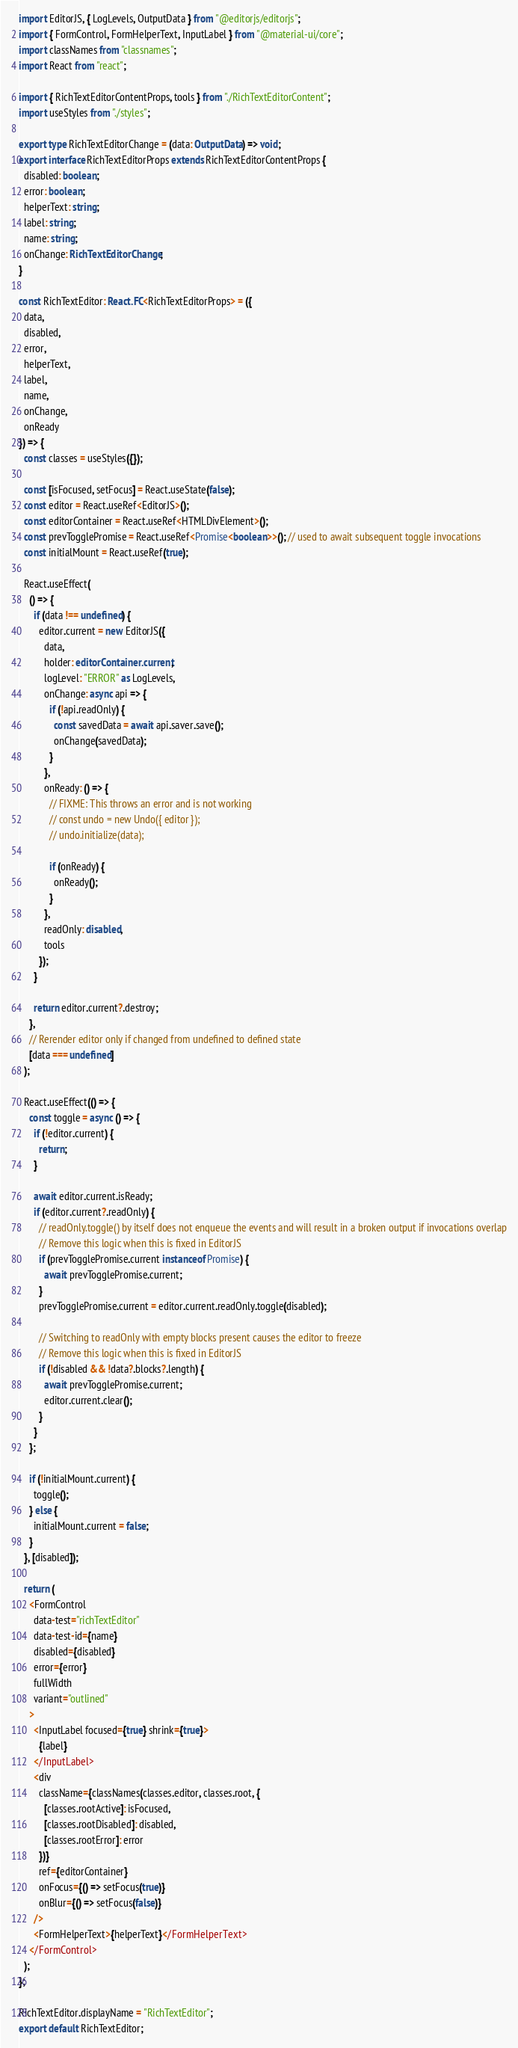<code> <loc_0><loc_0><loc_500><loc_500><_TypeScript_>import EditorJS, { LogLevels, OutputData } from "@editorjs/editorjs";
import { FormControl, FormHelperText, InputLabel } from "@material-ui/core";
import classNames from "classnames";
import React from "react";

import { RichTextEditorContentProps, tools } from "./RichTextEditorContent";
import useStyles from "./styles";

export type RichTextEditorChange = (data: OutputData) => void;
export interface RichTextEditorProps extends RichTextEditorContentProps {
  disabled: boolean;
  error: boolean;
  helperText: string;
  label: string;
  name: string;
  onChange: RichTextEditorChange;
}

const RichTextEditor: React.FC<RichTextEditorProps> = ({
  data,
  disabled,
  error,
  helperText,
  label,
  name,
  onChange,
  onReady
}) => {
  const classes = useStyles({});

  const [isFocused, setFocus] = React.useState(false);
  const editor = React.useRef<EditorJS>();
  const editorContainer = React.useRef<HTMLDivElement>();
  const prevTogglePromise = React.useRef<Promise<boolean>>(); // used to await subsequent toggle invocations
  const initialMount = React.useRef(true);

  React.useEffect(
    () => {
      if (data !== undefined) {
        editor.current = new EditorJS({
          data,
          holder: editorContainer.current,
          logLevel: "ERROR" as LogLevels,
          onChange: async api => {
            if (!api.readOnly) {
              const savedData = await api.saver.save();
              onChange(savedData);
            }
          },
          onReady: () => {
            // FIXME: This throws an error and is not working
            // const undo = new Undo({ editor });
            // undo.initialize(data);

            if (onReady) {
              onReady();
            }
          },
          readOnly: disabled,
          tools
        });
      }

      return editor.current?.destroy;
    },
    // Rerender editor only if changed from undefined to defined state
    [data === undefined]
  );

  React.useEffect(() => {
    const toggle = async () => {
      if (!editor.current) {
        return;
      }

      await editor.current.isReady;
      if (editor.current?.readOnly) {
        // readOnly.toggle() by itself does not enqueue the events and will result in a broken output if invocations overlap
        // Remove this logic when this is fixed in EditorJS
        if (prevTogglePromise.current instanceof Promise) {
          await prevTogglePromise.current;
        }
        prevTogglePromise.current = editor.current.readOnly.toggle(disabled);

        // Switching to readOnly with empty blocks present causes the editor to freeze
        // Remove this logic when this is fixed in EditorJS
        if (!disabled && !data?.blocks?.length) {
          await prevTogglePromise.current;
          editor.current.clear();
        }
      }
    };

    if (!initialMount.current) {
      toggle();
    } else {
      initialMount.current = false;
    }
  }, [disabled]);

  return (
    <FormControl
      data-test="richTextEditor"
      data-test-id={name}
      disabled={disabled}
      error={error}
      fullWidth
      variant="outlined"
    >
      <InputLabel focused={true} shrink={true}>
        {label}
      </InputLabel>
      <div
        className={classNames(classes.editor, classes.root, {
          [classes.rootActive]: isFocused,
          [classes.rootDisabled]: disabled,
          [classes.rootError]: error
        })}
        ref={editorContainer}
        onFocus={() => setFocus(true)}
        onBlur={() => setFocus(false)}
      />
      <FormHelperText>{helperText}</FormHelperText>
    </FormControl>
  );
};

RichTextEditor.displayName = "RichTextEditor";
export default RichTextEditor;
</code> 